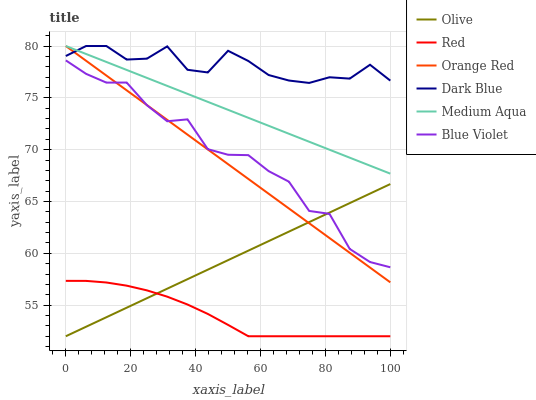Does Red have the minimum area under the curve?
Answer yes or no. Yes. Does Dark Blue have the maximum area under the curve?
Answer yes or no. Yes. Does Medium Aqua have the minimum area under the curve?
Answer yes or no. No. Does Medium Aqua have the maximum area under the curve?
Answer yes or no. No. Is Olive the smoothest?
Answer yes or no. Yes. Is Blue Violet the roughest?
Answer yes or no. Yes. Is Medium Aqua the smoothest?
Answer yes or no. No. Is Medium Aqua the roughest?
Answer yes or no. No. Does Red have the lowest value?
Answer yes or no. Yes. Does Medium Aqua have the lowest value?
Answer yes or no. No. Does Orange Red have the highest value?
Answer yes or no. Yes. Does Red have the highest value?
Answer yes or no. No. Is Olive less than Dark Blue?
Answer yes or no. Yes. Is Dark Blue greater than Olive?
Answer yes or no. Yes. Does Red intersect Olive?
Answer yes or no. Yes. Is Red less than Olive?
Answer yes or no. No. Is Red greater than Olive?
Answer yes or no. No. Does Olive intersect Dark Blue?
Answer yes or no. No. 